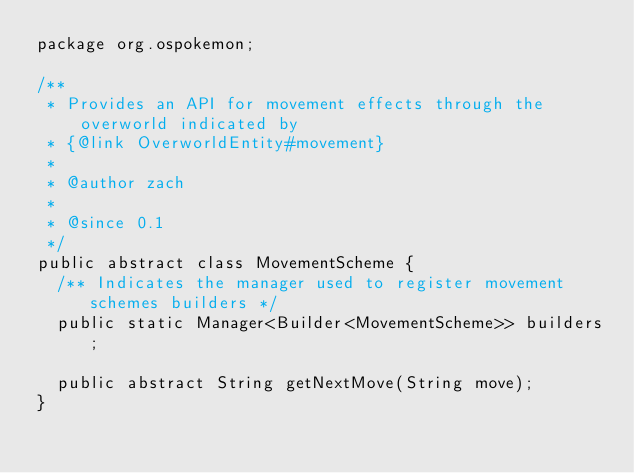Convert code to text. <code><loc_0><loc_0><loc_500><loc_500><_Java_>package org.ospokemon;

/**
 * Provides an API for movement effects through the overworld indicated by
 * {@link OverworldEntity#movement}
 * 
 * @author zach
 *
 * @since 0.1
 */
public abstract class MovementScheme {
	/** Indicates the manager used to register movement schemes builders */
	public static Manager<Builder<MovementScheme>> builders;

	public abstract String getNextMove(String move);
}
</code> 